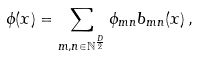<formula> <loc_0><loc_0><loc_500><loc_500>\phi ( x ) = \sum _ { m , n \in \mathbb { N } ^ { \frac { D } { 2 } } } \phi _ { m n } b _ { m n } ( x ) \, ,</formula> 